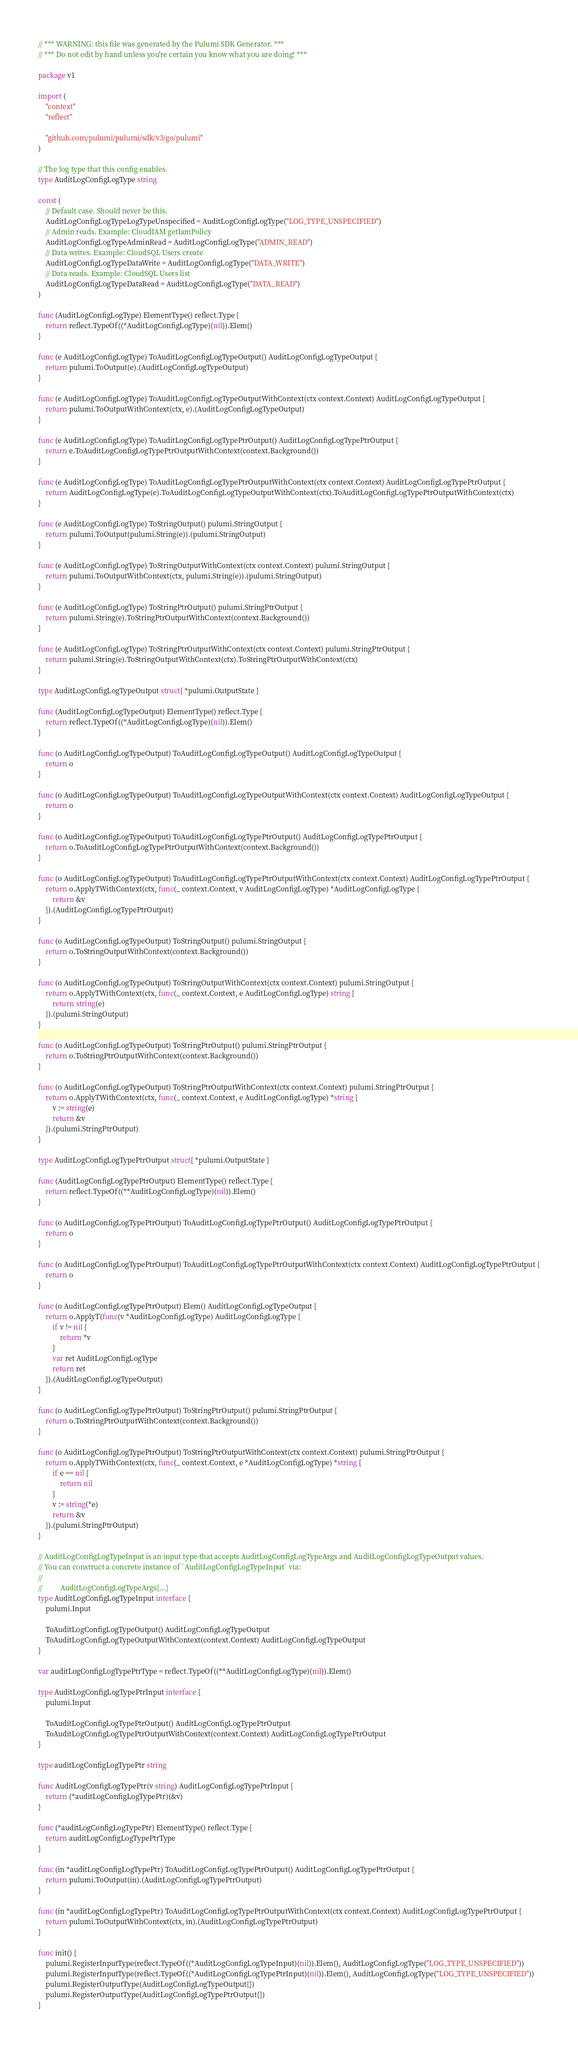<code> <loc_0><loc_0><loc_500><loc_500><_Go_>// *** WARNING: this file was generated by the Pulumi SDK Generator. ***
// *** Do not edit by hand unless you're certain you know what you are doing! ***

package v1

import (
	"context"
	"reflect"

	"github.com/pulumi/pulumi/sdk/v3/go/pulumi"
)

// The log type that this config enables.
type AuditLogConfigLogType string

const (
	// Default case. Should never be this.
	AuditLogConfigLogTypeLogTypeUnspecified = AuditLogConfigLogType("LOG_TYPE_UNSPECIFIED")
	// Admin reads. Example: CloudIAM getIamPolicy
	AuditLogConfigLogTypeAdminRead = AuditLogConfigLogType("ADMIN_READ")
	// Data writes. Example: CloudSQL Users create
	AuditLogConfigLogTypeDataWrite = AuditLogConfigLogType("DATA_WRITE")
	// Data reads. Example: CloudSQL Users list
	AuditLogConfigLogTypeDataRead = AuditLogConfigLogType("DATA_READ")
)

func (AuditLogConfigLogType) ElementType() reflect.Type {
	return reflect.TypeOf((*AuditLogConfigLogType)(nil)).Elem()
}

func (e AuditLogConfigLogType) ToAuditLogConfigLogTypeOutput() AuditLogConfigLogTypeOutput {
	return pulumi.ToOutput(e).(AuditLogConfigLogTypeOutput)
}

func (e AuditLogConfigLogType) ToAuditLogConfigLogTypeOutputWithContext(ctx context.Context) AuditLogConfigLogTypeOutput {
	return pulumi.ToOutputWithContext(ctx, e).(AuditLogConfigLogTypeOutput)
}

func (e AuditLogConfigLogType) ToAuditLogConfigLogTypePtrOutput() AuditLogConfigLogTypePtrOutput {
	return e.ToAuditLogConfigLogTypePtrOutputWithContext(context.Background())
}

func (e AuditLogConfigLogType) ToAuditLogConfigLogTypePtrOutputWithContext(ctx context.Context) AuditLogConfigLogTypePtrOutput {
	return AuditLogConfigLogType(e).ToAuditLogConfigLogTypeOutputWithContext(ctx).ToAuditLogConfigLogTypePtrOutputWithContext(ctx)
}

func (e AuditLogConfigLogType) ToStringOutput() pulumi.StringOutput {
	return pulumi.ToOutput(pulumi.String(e)).(pulumi.StringOutput)
}

func (e AuditLogConfigLogType) ToStringOutputWithContext(ctx context.Context) pulumi.StringOutput {
	return pulumi.ToOutputWithContext(ctx, pulumi.String(e)).(pulumi.StringOutput)
}

func (e AuditLogConfigLogType) ToStringPtrOutput() pulumi.StringPtrOutput {
	return pulumi.String(e).ToStringPtrOutputWithContext(context.Background())
}

func (e AuditLogConfigLogType) ToStringPtrOutputWithContext(ctx context.Context) pulumi.StringPtrOutput {
	return pulumi.String(e).ToStringOutputWithContext(ctx).ToStringPtrOutputWithContext(ctx)
}

type AuditLogConfigLogTypeOutput struct{ *pulumi.OutputState }

func (AuditLogConfigLogTypeOutput) ElementType() reflect.Type {
	return reflect.TypeOf((*AuditLogConfigLogType)(nil)).Elem()
}

func (o AuditLogConfigLogTypeOutput) ToAuditLogConfigLogTypeOutput() AuditLogConfigLogTypeOutput {
	return o
}

func (o AuditLogConfigLogTypeOutput) ToAuditLogConfigLogTypeOutputWithContext(ctx context.Context) AuditLogConfigLogTypeOutput {
	return o
}

func (o AuditLogConfigLogTypeOutput) ToAuditLogConfigLogTypePtrOutput() AuditLogConfigLogTypePtrOutput {
	return o.ToAuditLogConfigLogTypePtrOutputWithContext(context.Background())
}

func (o AuditLogConfigLogTypeOutput) ToAuditLogConfigLogTypePtrOutputWithContext(ctx context.Context) AuditLogConfigLogTypePtrOutput {
	return o.ApplyTWithContext(ctx, func(_ context.Context, v AuditLogConfigLogType) *AuditLogConfigLogType {
		return &v
	}).(AuditLogConfigLogTypePtrOutput)
}

func (o AuditLogConfigLogTypeOutput) ToStringOutput() pulumi.StringOutput {
	return o.ToStringOutputWithContext(context.Background())
}

func (o AuditLogConfigLogTypeOutput) ToStringOutputWithContext(ctx context.Context) pulumi.StringOutput {
	return o.ApplyTWithContext(ctx, func(_ context.Context, e AuditLogConfigLogType) string {
		return string(e)
	}).(pulumi.StringOutput)
}

func (o AuditLogConfigLogTypeOutput) ToStringPtrOutput() pulumi.StringPtrOutput {
	return o.ToStringPtrOutputWithContext(context.Background())
}

func (o AuditLogConfigLogTypeOutput) ToStringPtrOutputWithContext(ctx context.Context) pulumi.StringPtrOutput {
	return o.ApplyTWithContext(ctx, func(_ context.Context, e AuditLogConfigLogType) *string {
		v := string(e)
		return &v
	}).(pulumi.StringPtrOutput)
}

type AuditLogConfigLogTypePtrOutput struct{ *pulumi.OutputState }

func (AuditLogConfigLogTypePtrOutput) ElementType() reflect.Type {
	return reflect.TypeOf((**AuditLogConfigLogType)(nil)).Elem()
}

func (o AuditLogConfigLogTypePtrOutput) ToAuditLogConfigLogTypePtrOutput() AuditLogConfigLogTypePtrOutput {
	return o
}

func (o AuditLogConfigLogTypePtrOutput) ToAuditLogConfigLogTypePtrOutputWithContext(ctx context.Context) AuditLogConfigLogTypePtrOutput {
	return o
}

func (o AuditLogConfigLogTypePtrOutput) Elem() AuditLogConfigLogTypeOutput {
	return o.ApplyT(func(v *AuditLogConfigLogType) AuditLogConfigLogType {
		if v != nil {
			return *v
		}
		var ret AuditLogConfigLogType
		return ret
	}).(AuditLogConfigLogTypeOutput)
}

func (o AuditLogConfigLogTypePtrOutput) ToStringPtrOutput() pulumi.StringPtrOutput {
	return o.ToStringPtrOutputWithContext(context.Background())
}

func (o AuditLogConfigLogTypePtrOutput) ToStringPtrOutputWithContext(ctx context.Context) pulumi.StringPtrOutput {
	return o.ApplyTWithContext(ctx, func(_ context.Context, e *AuditLogConfigLogType) *string {
		if e == nil {
			return nil
		}
		v := string(*e)
		return &v
	}).(pulumi.StringPtrOutput)
}

// AuditLogConfigLogTypeInput is an input type that accepts AuditLogConfigLogTypeArgs and AuditLogConfigLogTypeOutput values.
// You can construct a concrete instance of `AuditLogConfigLogTypeInput` via:
//
//          AuditLogConfigLogTypeArgs{...}
type AuditLogConfigLogTypeInput interface {
	pulumi.Input

	ToAuditLogConfigLogTypeOutput() AuditLogConfigLogTypeOutput
	ToAuditLogConfigLogTypeOutputWithContext(context.Context) AuditLogConfigLogTypeOutput
}

var auditLogConfigLogTypePtrType = reflect.TypeOf((**AuditLogConfigLogType)(nil)).Elem()

type AuditLogConfigLogTypePtrInput interface {
	pulumi.Input

	ToAuditLogConfigLogTypePtrOutput() AuditLogConfigLogTypePtrOutput
	ToAuditLogConfigLogTypePtrOutputWithContext(context.Context) AuditLogConfigLogTypePtrOutput
}

type auditLogConfigLogTypePtr string

func AuditLogConfigLogTypePtr(v string) AuditLogConfigLogTypePtrInput {
	return (*auditLogConfigLogTypePtr)(&v)
}

func (*auditLogConfigLogTypePtr) ElementType() reflect.Type {
	return auditLogConfigLogTypePtrType
}

func (in *auditLogConfigLogTypePtr) ToAuditLogConfigLogTypePtrOutput() AuditLogConfigLogTypePtrOutput {
	return pulumi.ToOutput(in).(AuditLogConfigLogTypePtrOutput)
}

func (in *auditLogConfigLogTypePtr) ToAuditLogConfigLogTypePtrOutputWithContext(ctx context.Context) AuditLogConfigLogTypePtrOutput {
	return pulumi.ToOutputWithContext(ctx, in).(AuditLogConfigLogTypePtrOutput)
}

func init() {
	pulumi.RegisterInputType(reflect.TypeOf((*AuditLogConfigLogTypeInput)(nil)).Elem(), AuditLogConfigLogType("LOG_TYPE_UNSPECIFIED"))
	pulumi.RegisterInputType(reflect.TypeOf((*AuditLogConfigLogTypePtrInput)(nil)).Elem(), AuditLogConfigLogType("LOG_TYPE_UNSPECIFIED"))
	pulumi.RegisterOutputType(AuditLogConfigLogTypeOutput{})
	pulumi.RegisterOutputType(AuditLogConfigLogTypePtrOutput{})
}
</code> 